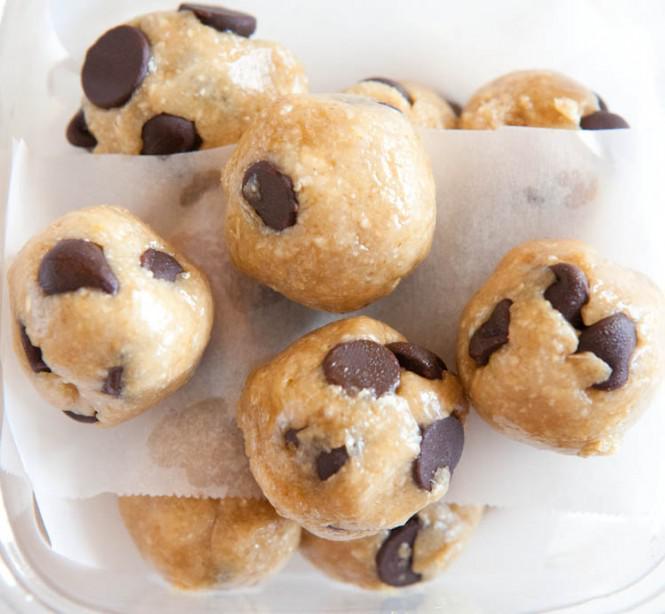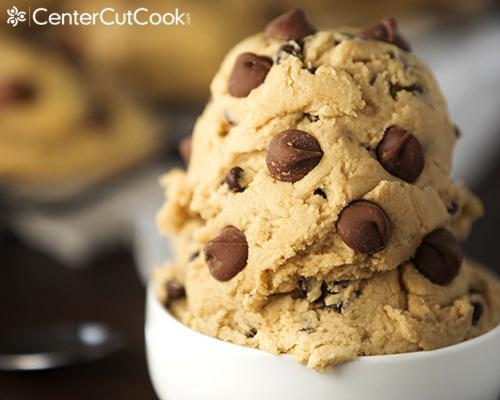The first image is the image on the left, the second image is the image on the right. For the images shown, is this caption "Someone is using a wooden spoon to make chocolate chip cookies in one of the pictures." true? Answer yes or no. No. The first image is the image on the left, the second image is the image on the right. Evaluate the accuracy of this statement regarding the images: "A wooden spoon touching dough is visible.". Is it true? Answer yes or no. No. 